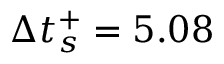<formula> <loc_0><loc_0><loc_500><loc_500>\Delta t _ { s } ^ { + } = 5 . 0 8</formula> 